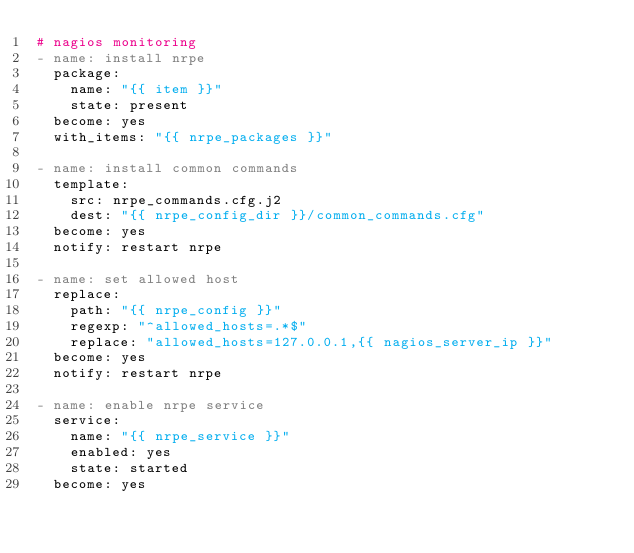Convert code to text. <code><loc_0><loc_0><loc_500><loc_500><_YAML_># nagios monitoring
- name: install nrpe
  package:
    name: "{{ item }}"
    state: present
  become: yes
  with_items: "{{ nrpe_packages }}"

- name: install common commands
  template:
    src: nrpe_commands.cfg.j2
    dest: "{{ nrpe_config_dir }}/common_commands.cfg"
  become: yes
  notify: restart nrpe

- name: set allowed host
  replace:
    path: "{{ nrpe_config }}"
    regexp: "^allowed_hosts=.*$"
    replace: "allowed_hosts=127.0.0.1,{{ nagios_server_ip }}"
  become: yes
  notify: restart nrpe

- name: enable nrpe service
  service:
    name: "{{ nrpe_service }}"
    enabled: yes
    state: started
  become: yes
</code> 